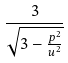<formula> <loc_0><loc_0><loc_500><loc_500>\frac { 3 } { \sqrt { 3 - \frac { p ^ { 2 } } { u ^ { 2 } } } }</formula> 